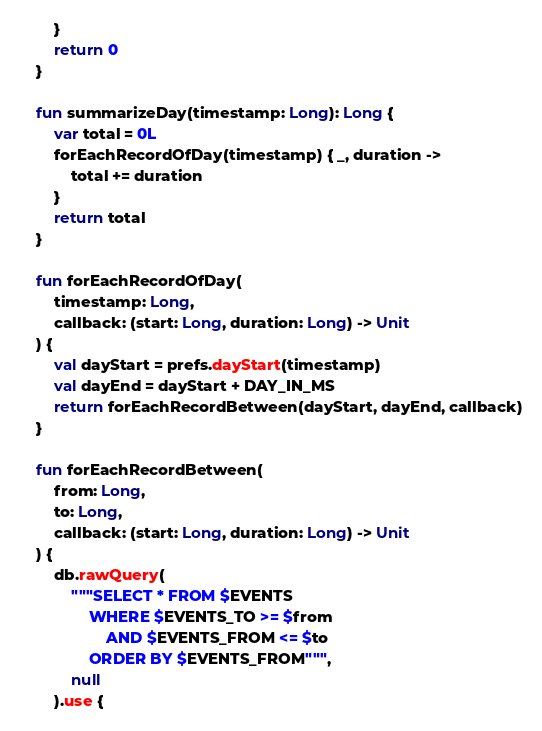Convert code to text. <code><loc_0><loc_0><loc_500><loc_500><_Kotlin_>		}
		return 0
	}

	fun summarizeDay(timestamp: Long): Long {
		var total = 0L
		forEachRecordOfDay(timestamp) { _, duration ->
			total += duration
		}
		return total
	}

	fun forEachRecordOfDay(
		timestamp: Long,
		callback: (start: Long, duration: Long) -> Unit
	) {
		val dayStart = prefs.dayStart(timestamp)
		val dayEnd = dayStart + DAY_IN_MS
		return forEachRecordBetween(dayStart, dayEnd, callback)
	}

	fun forEachRecordBetween(
		from: Long,
		to: Long,
		callback: (start: Long, duration: Long) -> Unit
	) {
		db.rawQuery(
			"""SELECT * FROM $EVENTS
				WHERE $EVENTS_TO >= $from
					AND $EVENTS_FROM <= $to
				ORDER BY $EVENTS_FROM""",
			null
		).use {</code> 